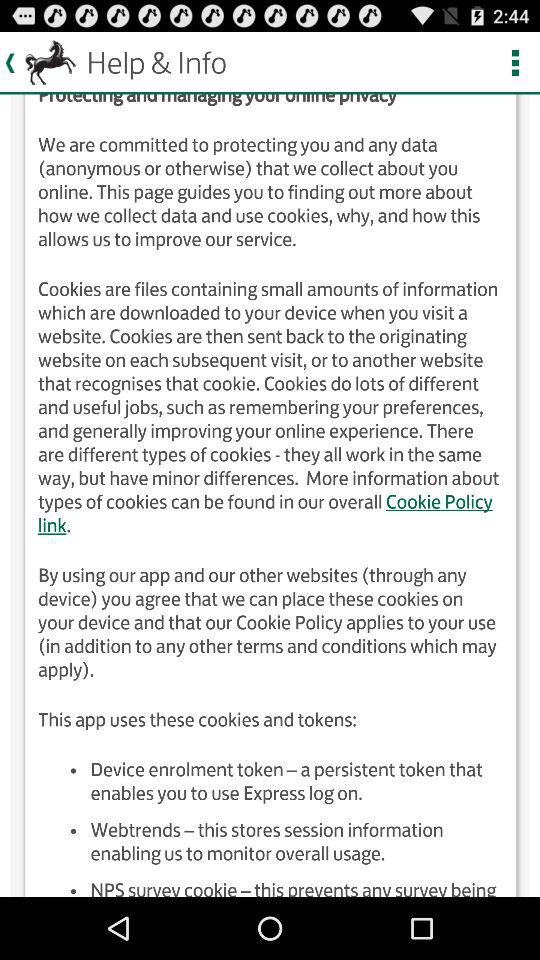How many different types of cookies are mentioned?
Answer the question using a single word or phrase. 3 